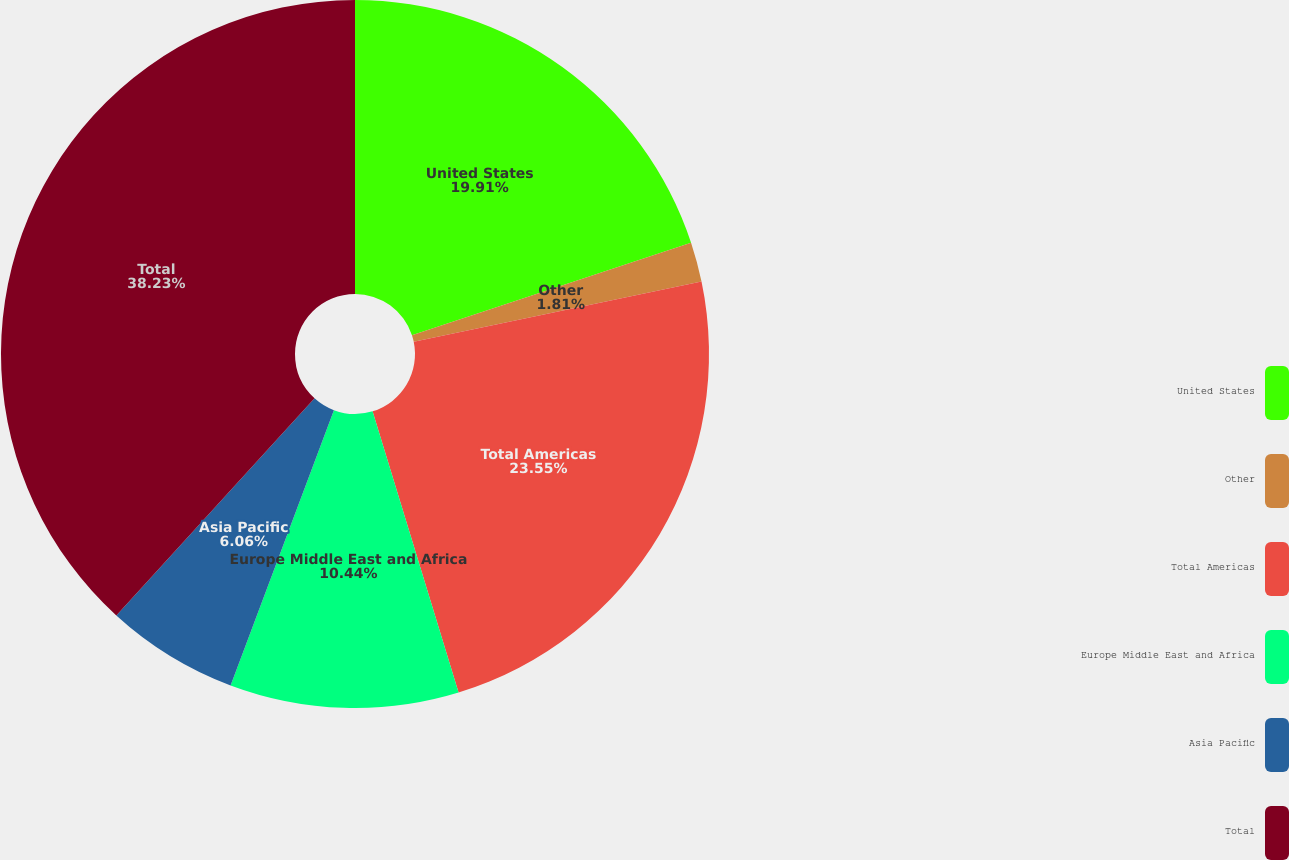<chart> <loc_0><loc_0><loc_500><loc_500><pie_chart><fcel>United States<fcel>Other<fcel>Total Americas<fcel>Europe Middle East and Africa<fcel>Asia Pacific<fcel>Total<nl><fcel>19.91%<fcel>1.81%<fcel>23.55%<fcel>10.44%<fcel>6.06%<fcel>38.22%<nl></chart> 